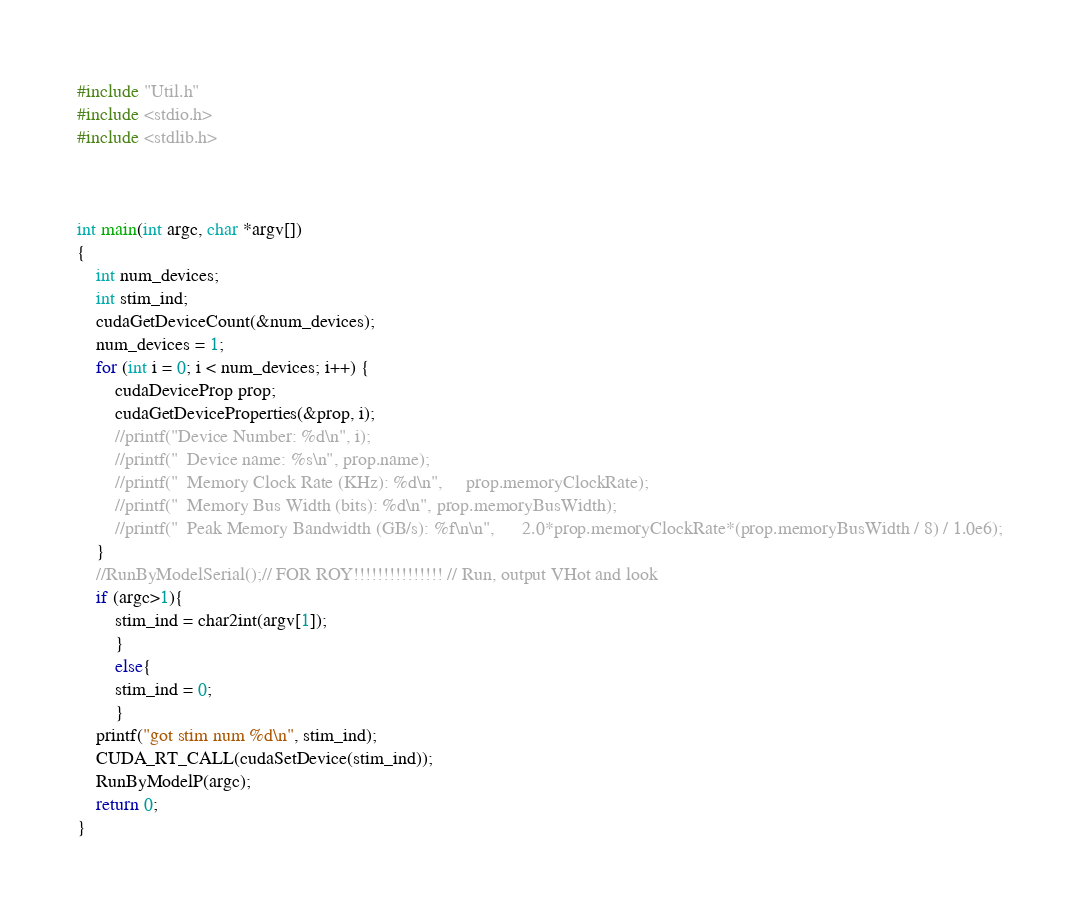<code> <loc_0><loc_0><loc_500><loc_500><_Cuda_>
#include "Util.h"
#include <stdio.h>
#include <stdlib.h>



int main(int argc, char *argv[])
{
	int num_devices;
    int stim_ind;
	cudaGetDeviceCount(&num_devices);
	num_devices = 1;
	for (int i = 0; i < num_devices; i++) {
		cudaDeviceProp prop;
		cudaGetDeviceProperties(&prop, i);
		//printf("Device Number: %d\n", i);
		//printf("  Device name: %s\n", prop.name);
		//printf("  Memory Clock Rate (KHz): %d\n",		prop.memoryClockRate);
		//printf("  Memory Bus Width (bits): %d\n",	prop.memoryBusWidth);
		//printf("  Peak Memory Bandwidth (GB/s): %f\n\n",		2.0*prop.memoryClockRate*(prop.memoryBusWidth / 8) / 1.0e6);
	}
	//RunByModelSerial();// FOR ROY!!!!!!!!!!!!!!! // Run, output VHot and look
    if (argc>1){
        stim_ind = char2int(argv[1]); 
        }
        else{
        stim_ind = 0;
        }
    printf("got stim num %d\n", stim_ind);
	CUDA_RT_CALL(cudaSetDevice(stim_ind));
	RunByModelP(argc);
	return 0;
}

</code> 